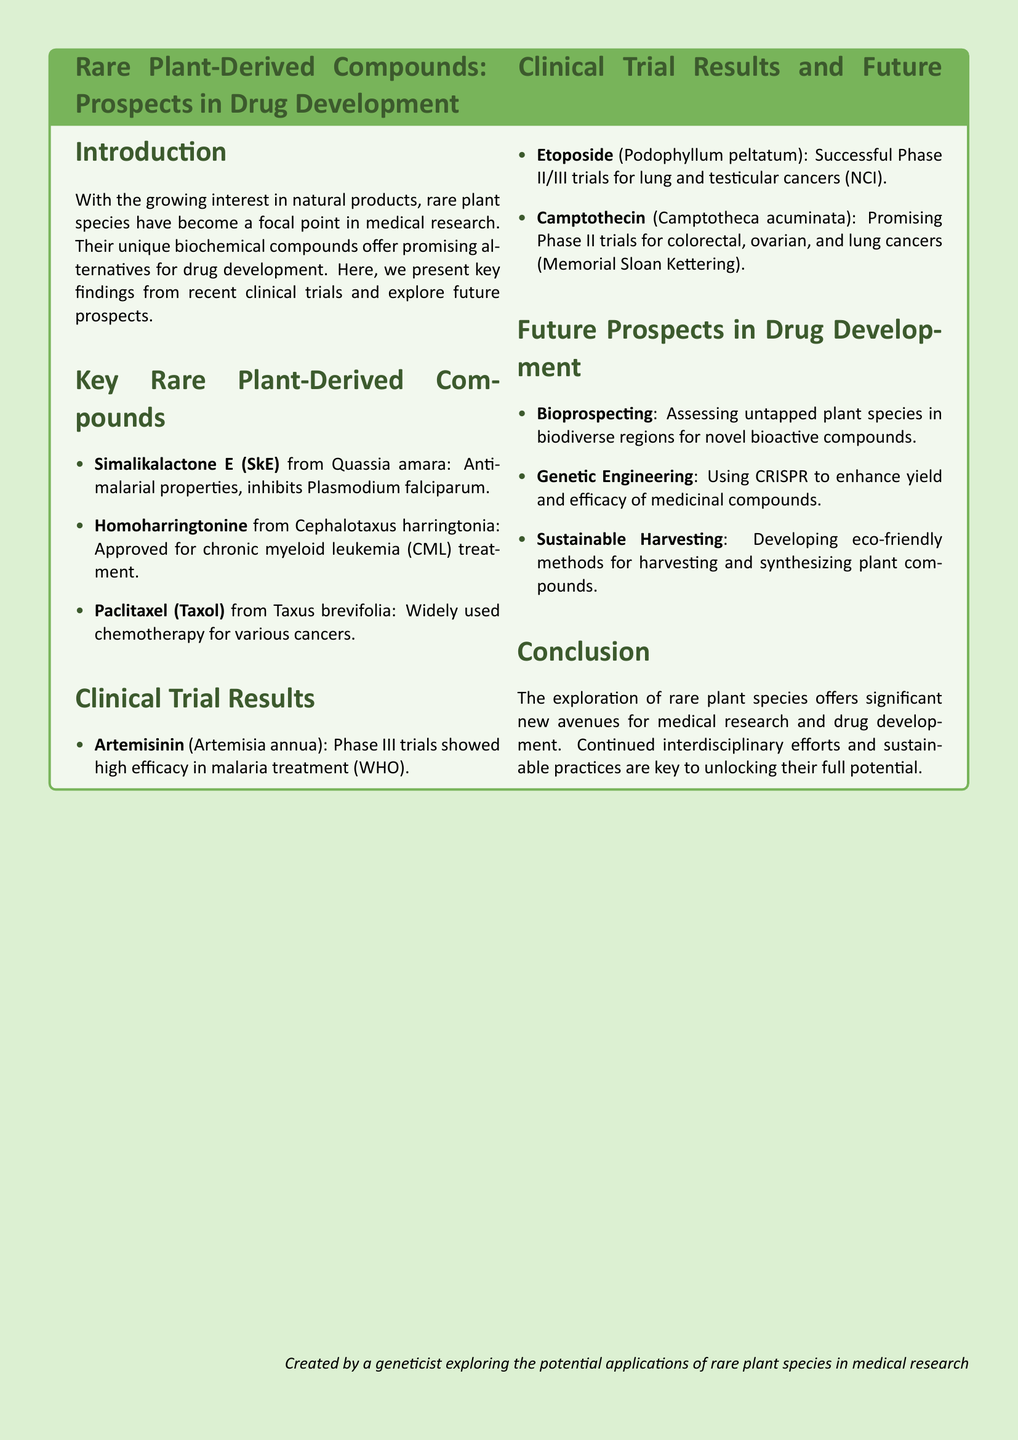What are the antimalarial properties of Simalikalactone E? Simalikalactone E has antimalarial properties and inhibits Plasmodium falciparum.
Answer: antimalarial properties, inhibits Plasmodium falciparum Which compound is approved for chronic myeloid leukemia treatment? The document states that Homoharringtonine from Cephalotaxus harringtonia is approved for chronic myeloid leukemia treatment.
Answer: Homoharringtonine What was shown in Phase III trials of Artemisinin? Phase III trials of Artemisinin showed high efficacy in malaria treatment according to WHO.
Answer: high efficacy in malaria treatment Which compound had successful Phase II/III trials for lung and testicular cancers? The document mentions that Etoposide from Podophyllum peltatum had successful Phase II/III trials for lung and testicular cancers.
Answer: Etoposide What is a future prospect mentioned for drug development regarding rare species? The document lists bioprospecting as a future prospect for drug development.
Answer: Bioprospecting How does the document categorize the future prospects in drug development? The future prospects in drug development are categorized into three main items as listed in the document.
Answer: Three main items What is the main focus of the introduction? The introduction focuses on the growing interest in natural products, specifically rare plant species in medical research.
Answer: growing interest in natural products Which organization is associated with Artemisinin's clinical trial results? The clinical trial results for Artemisinin are associated with the WHO.
Answer: WHO 